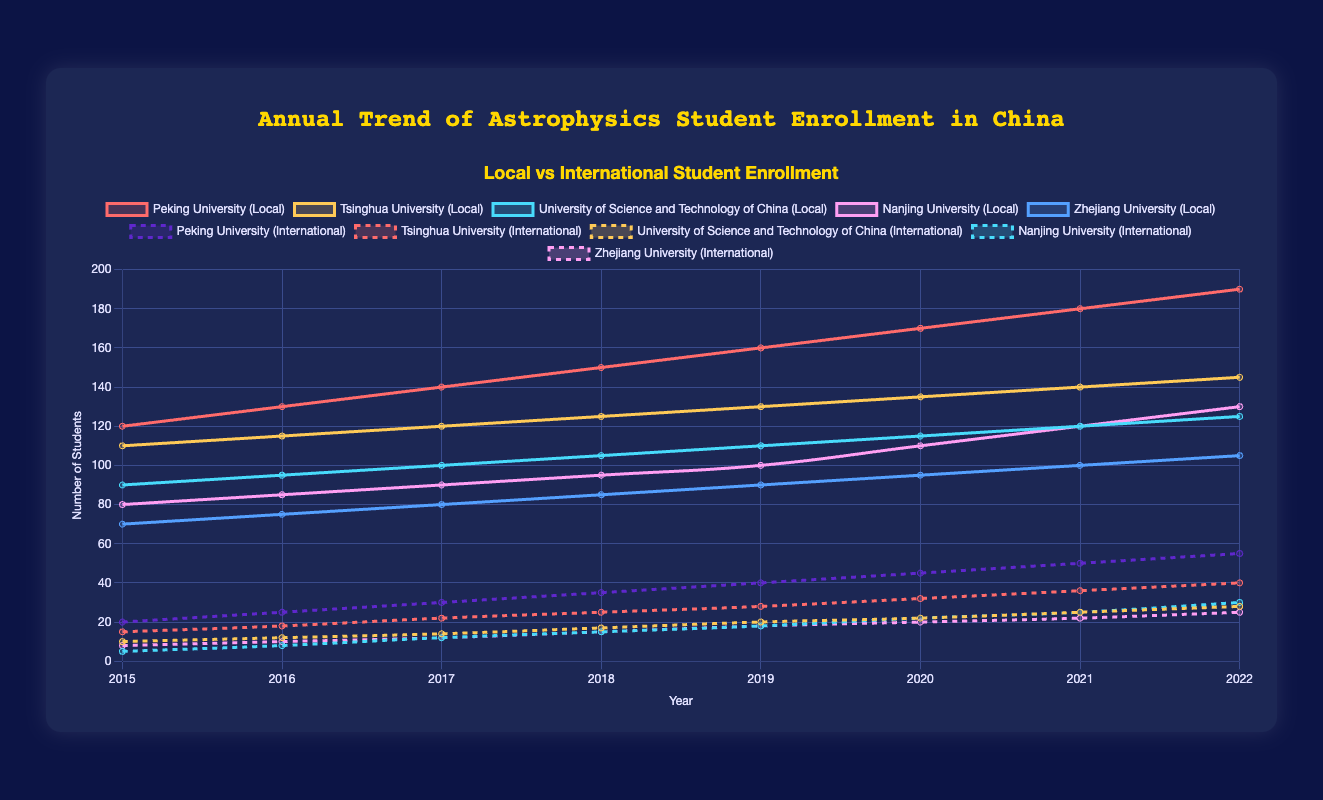What is the total number of local students enrolled in Tsinghua University in 2018? The plot shows the enrollment numbers for Tsinghua University local students in each year. Find the value for 2018, which is 125.
Answer: 125 How does the number of international students enrolled at Peking University in 2022 compare to the number in 2015? Check the plot for the enrollment numbers at Peking University for international students in 2015 and 2022. In 2015, it's 20, and in 2022, it's 55.
Answer: 55 is greater than 20 Which university had the highest increase in local student enrollment between 2015 and 2022? Calculate the difference in enrollment for each university between 2015 and 2022. Peking University: 190 - 120 = 70, Tsinghua University: 145 - 110 = 35, University of Science and Technology of China: 125 - 90 = 35, Nanjing University: 130 - 80 = 50, Zhejiang University: 105 - 70 = 35. The highest increase is 70 for Peking University.
Answer: Peking University What was the average number of international students enrolled at Tsinghua University over the years given? Retrieve the enrollment numbers for international students at Tsinghua University and calculate their average: (15 + 18 + 22 + 25 + 28 + 32 + 36 + 40)/8 = 27
Answer: 27 Which year saw the highest enrollment of both local and international students combined at Nanjing University? Sum the local and international enrollments for each year at Nanjing University. The year with the highest combined enrollment needs to be identified:
2015: 80 + 5 = 85,
2016: 85 + 8 = 93,
2017: 90 + 12 = 102,
2018: 95 + 15 = 110,
2019: 100 + 18 = 118,
2020: 110 + 22 = 132,
2021: 120 + 25 = 145,
2022: 130 + 30 = 160. The highest total is in 2022.
Answer: 2022 What is the difference in the number of local and international students enrolled at the University of Science and Technology of China in 2020? Find the enrollment numbers for local and international students at the University of Science and Technology of China in 2020. Local students: 115, International students: 22. The difference is 115 - 22 = 93.
Answer: 93 How many more international students are enrolled in Peking University compared to Zhejiang University in 2022? Find the number of international students enrolled in Peking University and Zhejiang University in 2022, then calculate the difference: 55 - 25 = 30.
Answer: 30 